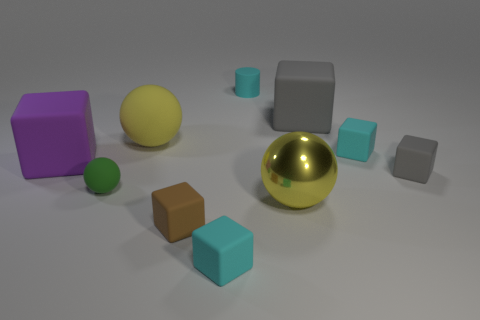Is there any indication of the scale or probable real-world size of these objects? No direct indications of scale or real-world size can be definitively determined from the image alone, as there are no familiar objects or measurements for reference. However, they seem to be modeled with proportions that could resemble common size variations found in toy blocks or desktop decorative items. 